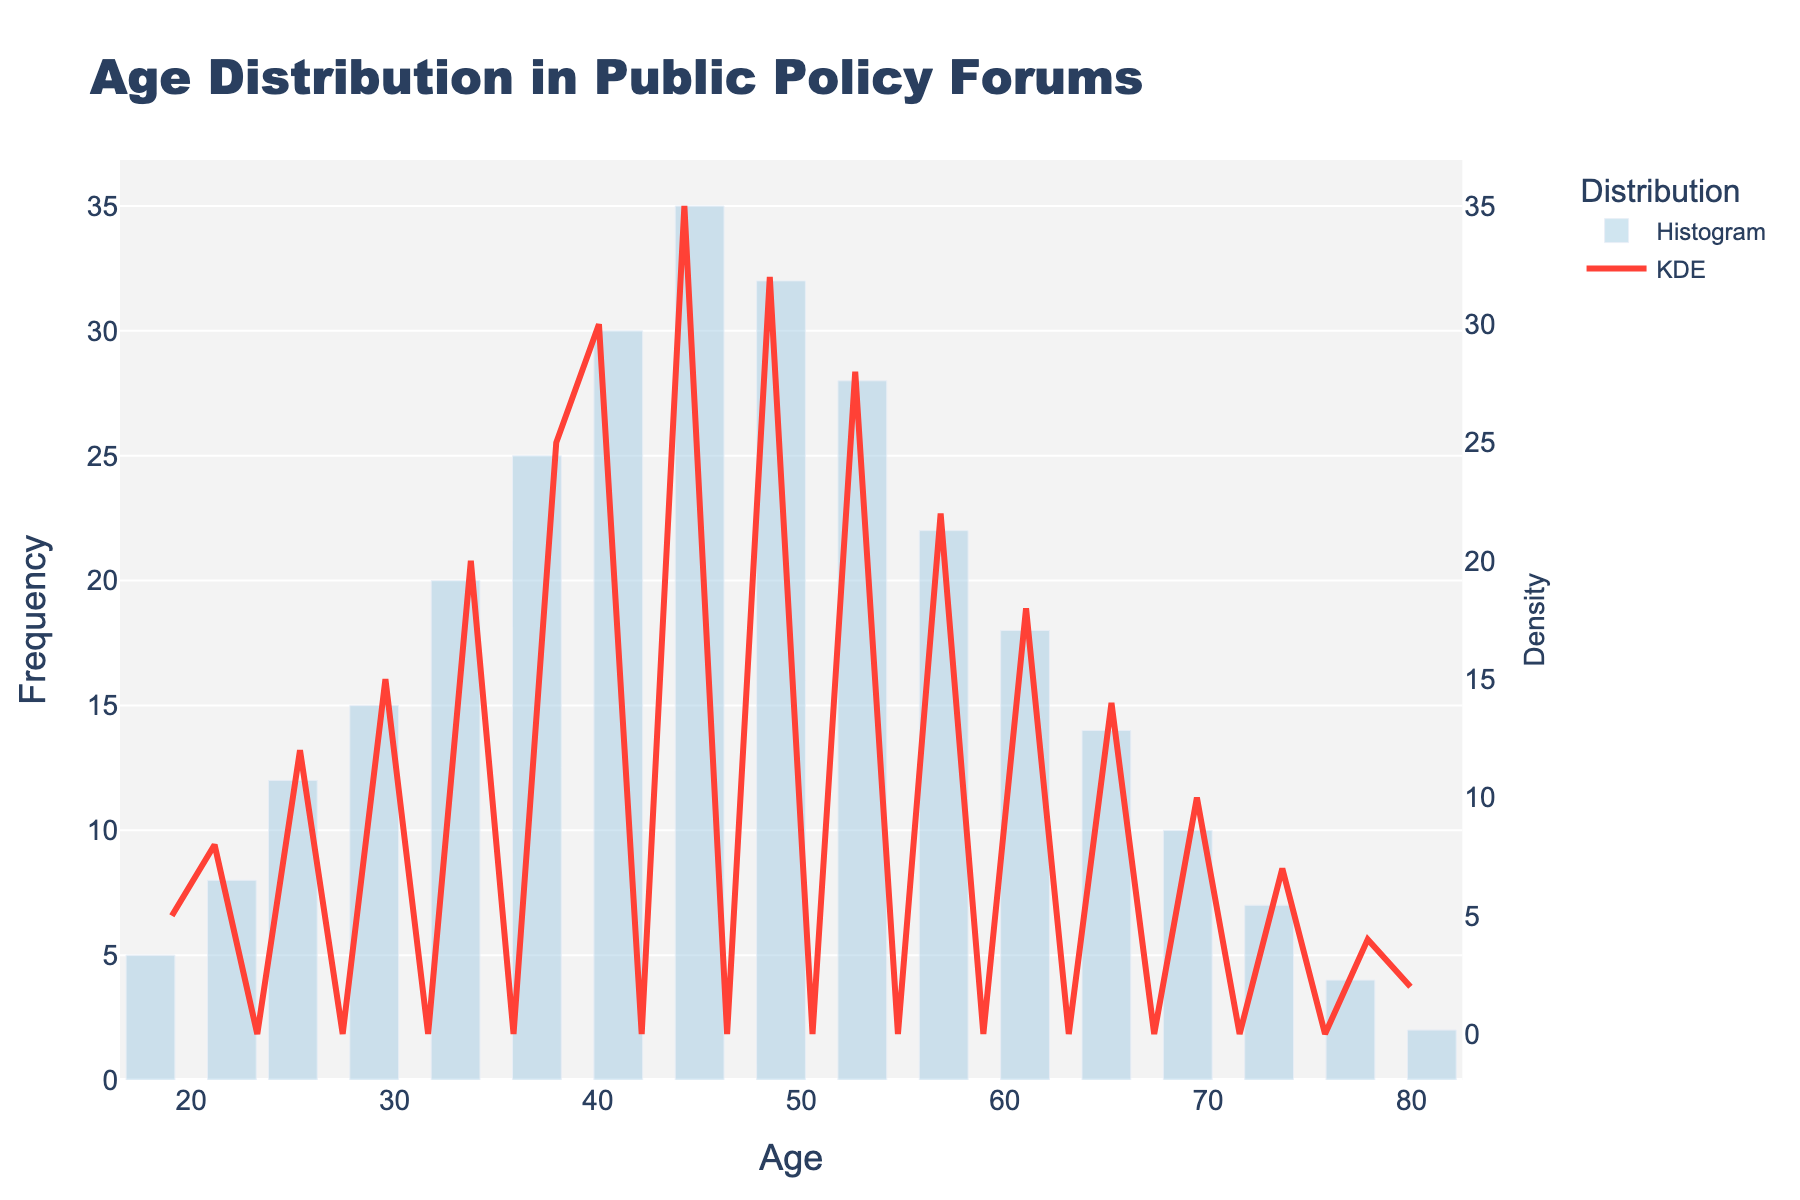What is the title of the figure? The title of the figure is located at the very top and is 'Age Distribution in Public Policy Forums'
Answer: Age Distribution in Public Policy Forums Which age group has the highest frequency in the histogram? The bar with the tallest height corresponds to the age group of 45, as indicated by the y-axis label 35
Answer: Age 45 At what age does the KDE curve show the highest density? The density curve (KDE) reaches its peak at the age where the line graph is the highest point, which is around the age 45
Answer: Age 45 What's the frequency difference between age 37 and age 57? Age 37 has a frequency of 25, and age 57 has a frequency of 22. The difference is calculated as 25 - 22
Answer: 3 What is the general trend observed in the age distribution as per the histogram? The histogram shows an initial increase in frequency as age increases until it peaks around age 45, and then it starts to decrease gradually
Answer: Increases, peaks at 45, then decreases Which age group has the lowest frequency of participant involvement in the town hall meetings? The bar with the shortest height indicates the age group with the lowest frequency, which is age 81 with a frequency of 2
Answer: Age 81 How does the density curve (KDE) help in interpreting the age distribution of the participants? The KDE curve smooths out the frequencies, showing the general trend without the jaggedness of the histogram. This curve reinforces the histogram’s peak around age 45, indicating that most participants are concentrated around this age
Answer: Shows smoothed trends, confirms peak around age 45 Compare the participant frequency between the age groups 49 and 65. Which group is higher and by how much? Age 49 has a frequency of 32, and age 65 has a frequency of 14. The difference is 32 - 14
Answer: Age 49, by 18 Does the figure suggest that younger or older individuals are more prevalent in public policy forums? Considering both histograms and KDE curve, older individuals (around age 45) exhibit the highest frequency and density, making them more prevalent compared to younger individuals
Answer: Older individuals How does the secondary y-axis enhance the figure's interpretation? The secondary y-axis labeled "Density" scales the density curve (KDE) properly, aligning it with the histogram's frequency, making it easier to visualize and compare both distributions simultaneously
Answer: Aligns KDE with frequency 